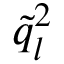Convert formula to latex. <formula><loc_0><loc_0><loc_500><loc_500>\tilde { q } _ { l } ^ { 2 }</formula> 